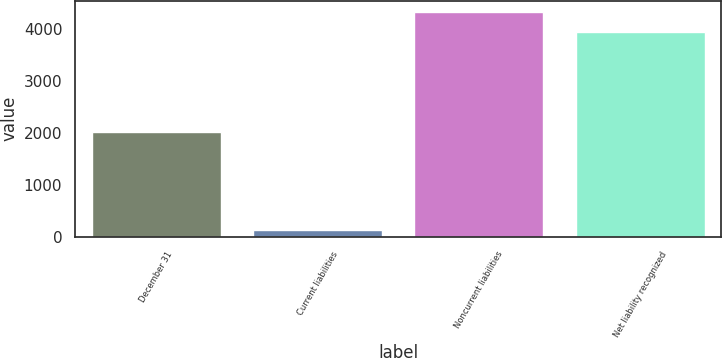Convert chart. <chart><loc_0><loc_0><loc_500><loc_500><bar_chart><fcel>December 31<fcel>Current liabilities<fcel>Noncurrent liabilities<fcel>Net liability recognized<nl><fcel>2015<fcel>125<fcel>4330.1<fcel>3946<nl></chart> 